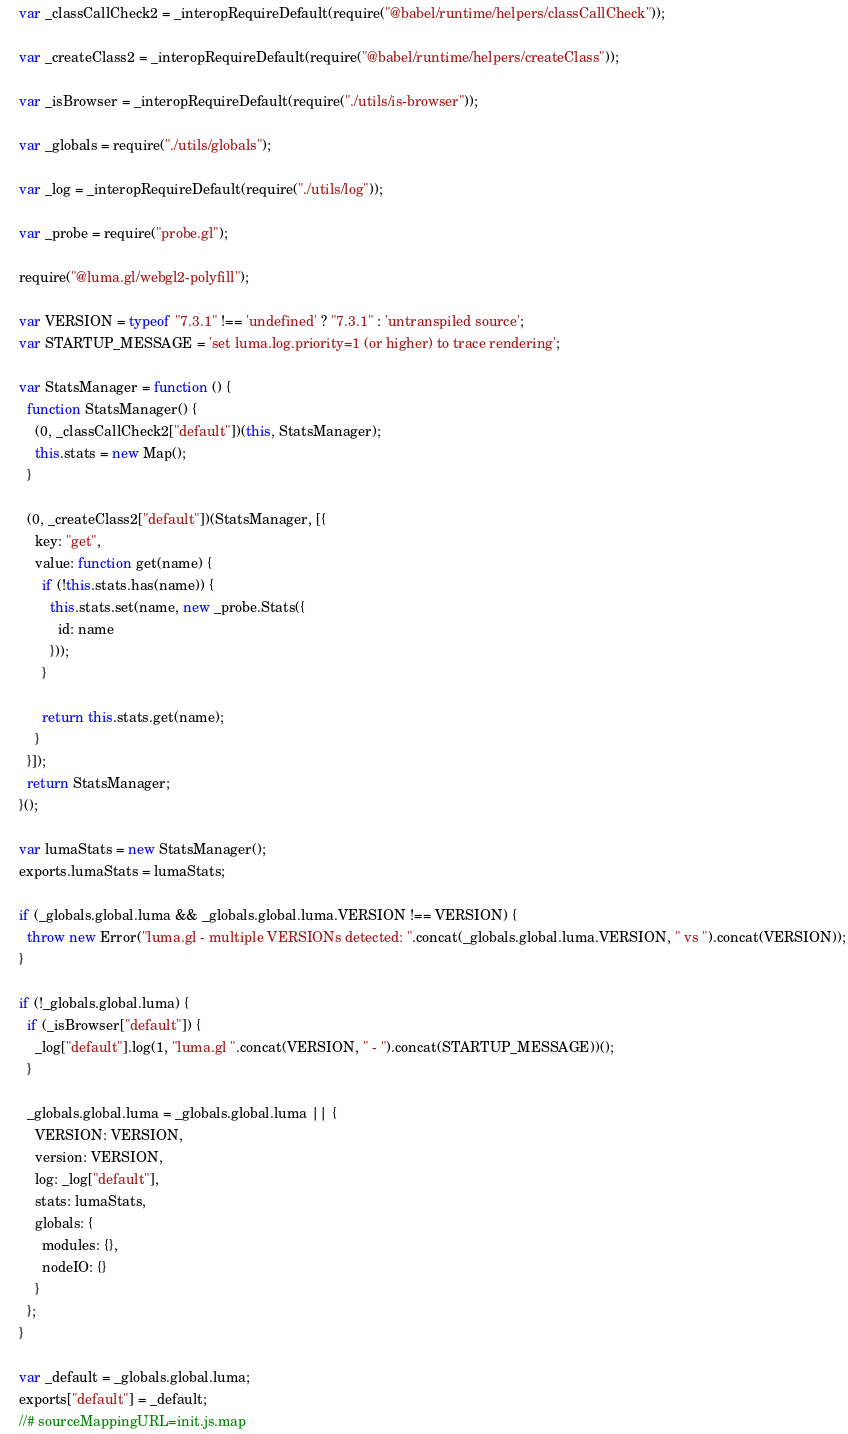Convert code to text. <code><loc_0><loc_0><loc_500><loc_500><_JavaScript_>
var _classCallCheck2 = _interopRequireDefault(require("@babel/runtime/helpers/classCallCheck"));

var _createClass2 = _interopRequireDefault(require("@babel/runtime/helpers/createClass"));

var _isBrowser = _interopRequireDefault(require("./utils/is-browser"));

var _globals = require("./utils/globals");

var _log = _interopRequireDefault(require("./utils/log"));

var _probe = require("probe.gl");

require("@luma.gl/webgl2-polyfill");

var VERSION = typeof "7.3.1" !== 'undefined' ? "7.3.1" : 'untranspiled source';
var STARTUP_MESSAGE = 'set luma.log.priority=1 (or higher) to trace rendering';

var StatsManager = function () {
  function StatsManager() {
    (0, _classCallCheck2["default"])(this, StatsManager);
    this.stats = new Map();
  }

  (0, _createClass2["default"])(StatsManager, [{
    key: "get",
    value: function get(name) {
      if (!this.stats.has(name)) {
        this.stats.set(name, new _probe.Stats({
          id: name
        }));
      }

      return this.stats.get(name);
    }
  }]);
  return StatsManager;
}();

var lumaStats = new StatsManager();
exports.lumaStats = lumaStats;

if (_globals.global.luma && _globals.global.luma.VERSION !== VERSION) {
  throw new Error("luma.gl - multiple VERSIONs detected: ".concat(_globals.global.luma.VERSION, " vs ").concat(VERSION));
}

if (!_globals.global.luma) {
  if (_isBrowser["default"]) {
    _log["default"].log(1, "luma.gl ".concat(VERSION, " - ").concat(STARTUP_MESSAGE))();
  }

  _globals.global.luma = _globals.global.luma || {
    VERSION: VERSION,
    version: VERSION,
    log: _log["default"],
    stats: lumaStats,
    globals: {
      modules: {},
      nodeIO: {}
    }
  };
}

var _default = _globals.global.luma;
exports["default"] = _default;
//# sourceMappingURL=init.js.map</code> 